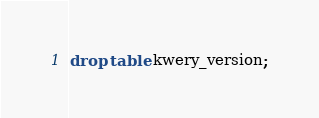<code> <loc_0><loc_0><loc_500><loc_500><_SQL_>drop table kwery_version;</code> 